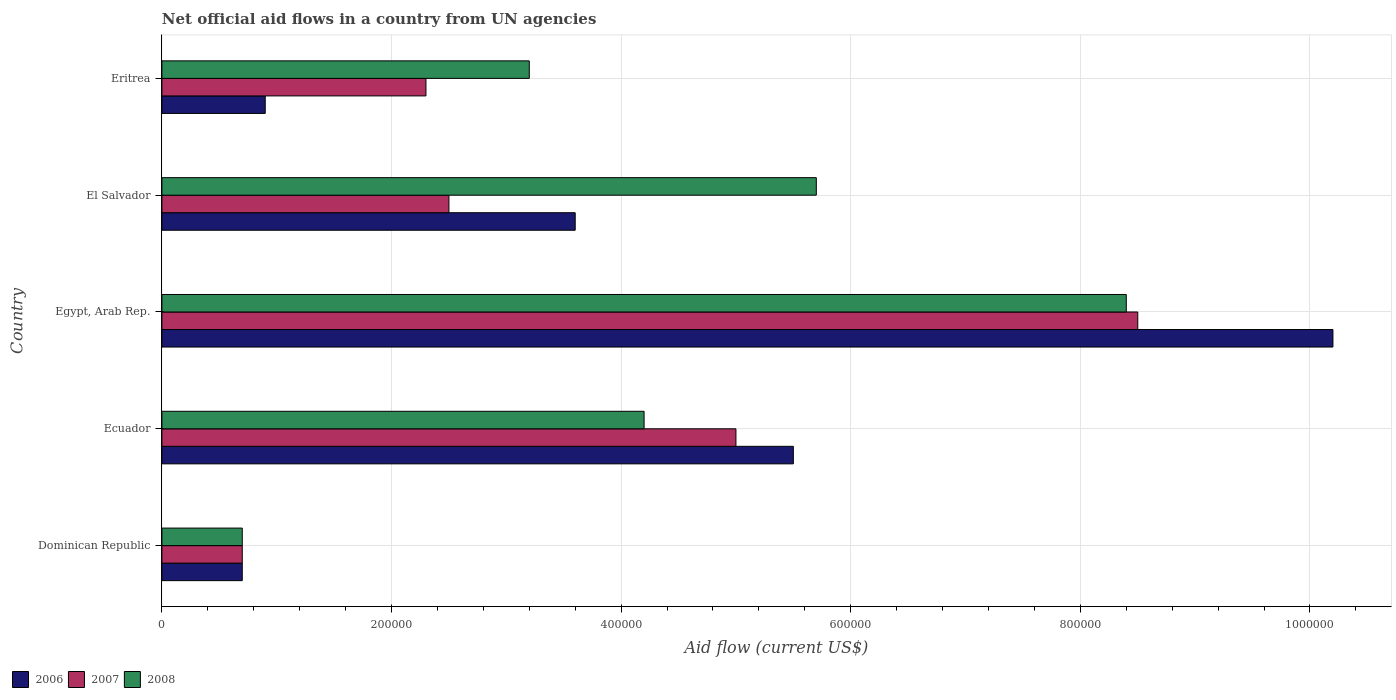How many different coloured bars are there?
Provide a succinct answer. 3. How many groups of bars are there?
Provide a succinct answer. 5. How many bars are there on the 3rd tick from the bottom?
Offer a terse response. 3. What is the label of the 2nd group of bars from the top?
Make the answer very short. El Salvador. Across all countries, what is the maximum net official aid flow in 2008?
Provide a succinct answer. 8.40e+05. Across all countries, what is the minimum net official aid flow in 2007?
Make the answer very short. 7.00e+04. In which country was the net official aid flow in 2008 maximum?
Offer a terse response. Egypt, Arab Rep. In which country was the net official aid flow in 2007 minimum?
Make the answer very short. Dominican Republic. What is the total net official aid flow in 2007 in the graph?
Give a very brief answer. 1.90e+06. What is the difference between the net official aid flow in 2006 in Ecuador and that in Eritrea?
Offer a terse response. 4.60e+05. What is the difference between the net official aid flow in 2006 in El Salvador and the net official aid flow in 2007 in Egypt, Arab Rep.?
Provide a succinct answer. -4.90e+05. What is the average net official aid flow in 2007 per country?
Keep it short and to the point. 3.80e+05. What is the difference between the net official aid flow in 2007 and net official aid flow in 2008 in Egypt, Arab Rep.?
Make the answer very short. 10000. Is the net official aid flow in 2008 in Egypt, Arab Rep. less than that in Eritrea?
Provide a succinct answer. No. Is the difference between the net official aid flow in 2007 in Ecuador and Egypt, Arab Rep. greater than the difference between the net official aid flow in 2008 in Ecuador and Egypt, Arab Rep.?
Your response must be concise. Yes. What is the difference between the highest and the second highest net official aid flow in 2007?
Provide a succinct answer. 3.50e+05. What is the difference between the highest and the lowest net official aid flow in 2007?
Keep it short and to the point. 7.80e+05. Is the sum of the net official aid flow in 2006 in Dominican Republic and Egypt, Arab Rep. greater than the maximum net official aid flow in 2008 across all countries?
Your response must be concise. Yes. What does the 2nd bar from the top in Eritrea represents?
Ensure brevity in your answer.  2007. What does the 3rd bar from the bottom in El Salvador represents?
Your answer should be very brief. 2008. Is it the case that in every country, the sum of the net official aid flow in 2007 and net official aid flow in 2006 is greater than the net official aid flow in 2008?
Ensure brevity in your answer.  No. Are all the bars in the graph horizontal?
Your answer should be very brief. Yes. How many countries are there in the graph?
Your response must be concise. 5. How many legend labels are there?
Make the answer very short. 3. What is the title of the graph?
Keep it short and to the point. Net official aid flows in a country from UN agencies. What is the Aid flow (current US$) in 2006 in Dominican Republic?
Give a very brief answer. 7.00e+04. What is the Aid flow (current US$) in 2008 in Dominican Republic?
Provide a short and direct response. 7.00e+04. What is the Aid flow (current US$) of 2006 in Ecuador?
Offer a very short reply. 5.50e+05. What is the Aid flow (current US$) of 2006 in Egypt, Arab Rep.?
Your response must be concise. 1.02e+06. What is the Aid flow (current US$) of 2007 in Egypt, Arab Rep.?
Make the answer very short. 8.50e+05. What is the Aid flow (current US$) of 2008 in Egypt, Arab Rep.?
Your answer should be compact. 8.40e+05. What is the Aid flow (current US$) in 2007 in El Salvador?
Provide a short and direct response. 2.50e+05. What is the Aid flow (current US$) in 2008 in El Salvador?
Make the answer very short. 5.70e+05. Across all countries, what is the maximum Aid flow (current US$) of 2006?
Offer a very short reply. 1.02e+06. Across all countries, what is the maximum Aid flow (current US$) of 2007?
Offer a very short reply. 8.50e+05. Across all countries, what is the maximum Aid flow (current US$) of 2008?
Provide a short and direct response. 8.40e+05. Across all countries, what is the minimum Aid flow (current US$) of 2007?
Provide a succinct answer. 7.00e+04. Across all countries, what is the minimum Aid flow (current US$) of 2008?
Give a very brief answer. 7.00e+04. What is the total Aid flow (current US$) of 2006 in the graph?
Keep it short and to the point. 2.09e+06. What is the total Aid flow (current US$) in 2007 in the graph?
Your response must be concise. 1.90e+06. What is the total Aid flow (current US$) in 2008 in the graph?
Keep it short and to the point. 2.22e+06. What is the difference between the Aid flow (current US$) in 2006 in Dominican Republic and that in Ecuador?
Your response must be concise. -4.80e+05. What is the difference between the Aid flow (current US$) in 2007 in Dominican Republic and that in Ecuador?
Provide a succinct answer. -4.30e+05. What is the difference between the Aid flow (current US$) of 2008 in Dominican Republic and that in Ecuador?
Provide a succinct answer. -3.50e+05. What is the difference between the Aid flow (current US$) in 2006 in Dominican Republic and that in Egypt, Arab Rep.?
Keep it short and to the point. -9.50e+05. What is the difference between the Aid flow (current US$) of 2007 in Dominican Republic and that in Egypt, Arab Rep.?
Provide a succinct answer. -7.80e+05. What is the difference between the Aid flow (current US$) in 2008 in Dominican Republic and that in Egypt, Arab Rep.?
Offer a terse response. -7.70e+05. What is the difference between the Aid flow (current US$) in 2006 in Dominican Republic and that in El Salvador?
Provide a succinct answer. -2.90e+05. What is the difference between the Aid flow (current US$) in 2007 in Dominican Republic and that in El Salvador?
Keep it short and to the point. -1.80e+05. What is the difference between the Aid flow (current US$) in 2008 in Dominican Republic and that in El Salvador?
Keep it short and to the point. -5.00e+05. What is the difference between the Aid flow (current US$) of 2006 in Dominican Republic and that in Eritrea?
Offer a terse response. -2.00e+04. What is the difference between the Aid flow (current US$) of 2008 in Dominican Republic and that in Eritrea?
Your response must be concise. -2.50e+05. What is the difference between the Aid flow (current US$) of 2006 in Ecuador and that in Egypt, Arab Rep.?
Your answer should be compact. -4.70e+05. What is the difference between the Aid flow (current US$) in 2007 in Ecuador and that in Egypt, Arab Rep.?
Keep it short and to the point. -3.50e+05. What is the difference between the Aid flow (current US$) in 2008 in Ecuador and that in Egypt, Arab Rep.?
Make the answer very short. -4.20e+05. What is the difference between the Aid flow (current US$) of 2007 in Ecuador and that in El Salvador?
Keep it short and to the point. 2.50e+05. What is the difference between the Aid flow (current US$) of 2008 in Ecuador and that in El Salvador?
Ensure brevity in your answer.  -1.50e+05. What is the difference between the Aid flow (current US$) in 2007 in Ecuador and that in Eritrea?
Give a very brief answer. 2.70e+05. What is the difference between the Aid flow (current US$) in 2008 in Egypt, Arab Rep. and that in El Salvador?
Your answer should be very brief. 2.70e+05. What is the difference between the Aid flow (current US$) in 2006 in Egypt, Arab Rep. and that in Eritrea?
Provide a succinct answer. 9.30e+05. What is the difference between the Aid flow (current US$) in 2007 in Egypt, Arab Rep. and that in Eritrea?
Keep it short and to the point. 6.20e+05. What is the difference between the Aid flow (current US$) in 2008 in Egypt, Arab Rep. and that in Eritrea?
Offer a very short reply. 5.20e+05. What is the difference between the Aid flow (current US$) in 2008 in El Salvador and that in Eritrea?
Provide a short and direct response. 2.50e+05. What is the difference between the Aid flow (current US$) of 2006 in Dominican Republic and the Aid flow (current US$) of 2007 in Ecuador?
Provide a succinct answer. -4.30e+05. What is the difference between the Aid flow (current US$) of 2006 in Dominican Republic and the Aid flow (current US$) of 2008 in Ecuador?
Ensure brevity in your answer.  -3.50e+05. What is the difference between the Aid flow (current US$) in 2007 in Dominican Republic and the Aid flow (current US$) in 2008 in Ecuador?
Ensure brevity in your answer.  -3.50e+05. What is the difference between the Aid flow (current US$) in 2006 in Dominican Republic and the Aid flow (current US$) in 2007 in Egypt, Arab Rep.?
Provide a short and direct response. -7.80e+05. What is the difference between the Aid flow (current US$) in 2006 in Dominican Republic and the Aid flow (current US$) in 2008 in Egypt, Arab Rep.?
Keep it short and to the point. -7.70e+05. What is the difference between the Aid flow (current US$) of 2007 in Dominican Republic and the Aid flow (current US$) of 2008 in Egypt, Arab Rep.?
Ensure brevity in your answer.  -7.70e+05. What is the difference between the Aid flow (current US$) of 2006 in Dominican Republic and the Aid flow (current US$) of 2008 in El Salvador?
Give a very brief answer. -5.00e+05. What is the difference between the Aid flow (current US$) of 2007 in Dominican Republic and the Aid flow (current US$) of 2008 in El Salvador?
Ensure brevity in your answer.  -5.00e+05. What is the difference between the Aid flow (current US$) of 2006 in Dominican Republic and the Aid flow (current US$) of 2007 in Eritrea?
Your answer should be very brief. -1.60e+05. What is the difference between the Aid flow (current US$) of 2006 in Ecuador and the Aid flow (current US$) of 2008 in Egypt, Arab Rep.?
Your response must be concise. -2.90e+05. What is the difference between the Aid flow (current US$) in 2007 in Ecuador and the Aid flow (current US$) in 2008 in Egypt, Arab Rep.?
Ensure brevity in your answer.  -3.40e+05. What is the difference between the Aid flow (current US$) in 2006 in Ecuador and the Aid flow (current US$) in 2007 in Eritrea?
Your response must be concise. 3.20e+05. What is the difference between the Aid flow (current US$) of 2006 in Egypt, Arab Rep. and the Aid flow (current US$) of 2007 in El Salvador?
Offer a terse response. 7.70e+05. What is the difference between the Aid flow (current US$) of 2007 in Egypt, Arab Rep. and the Aid flow (current US$) of 2008 in El Salvador?
Ensure brevity in your answer.  2.80e+05. What is the difference between the Aid flow (current US$) in 2006 in Egypt, Arab Rep. and the Aid flow (current US$) in 2007 in Eritrea?
Offer a very short reply. 7.90e+05. What is the difference between the Aid flow (current US$) in 2007 in Egypt, Arab Rep. and the Aid flow (current US$) in 2008 in Eritrea?
Provide a succinct answer. 5.30e+05. What is the difference between the Aid flow (current US$) in 2006 in El Salvador and the Aid flow (current US$) in 2007 in Eritrea?
Your response must be concise. 1.30e+05. What is the difference between the Aid flow (current US$) of 2006 in El Salvador and the Aid flow (current US$) of 2008 in Eritrea?
Provide a short and direct response. 4.00e+04. What is the difference between the Aid flow (current US$) of 2007 in El Salvador and the Aid flow (current US$) of 2008 in Eritrea?
Ensure brevity in your answer.  -7.00e+04. What is the average Aid flow (current US$) of 2006 per country?
Give a very brief answer. 4.18e+05. What is the average Aid flow (current US$) in 2008 per country?
Make the answer very short. 4.44e+05. What is the difference between the Aid flow (current US$) of 2006 and Aid flow (current US$) of 2007 in Dominican Republic?
Make the answer very short. 0. What is the difference between the Aid flow (current US$) of 2006 and Aid flow (current US$) of 2008 in Dominican Republic?
Offer a terse response. 0. What is the difference between the Aid flow (current US$) of 2006 and Aid flow (current US$) of 2008 in Egypt, Arab Rep.?
Provide a succinct answer. 1.80e+05. What is the difference between the Aid flow (current US$) of 2007 and Aid flow (current US$) of 2008 in Egypt, Arab Rep.?
Make the answer very short. 10000. What is the difference between the Aid flow (current US$) of 2006 and Aid flow (current US$) of 2007 in El Salvador?
Make the answer very short. 1.10e+05. What is the difference between the Aid flow (current US$) in 2007 and Aid flow (current US$) in 2008 in El Salvador?
Keep it short and to the point. -3.20e+05. What is the ratio of the Aid flow (current US$) in 2006 in Dominican Republic to that in Ecuador?
Offer a terse response. 0.13. What is the ratio of the Aid flow (current US$) in 2007 in Dominican Republic to that in Ecuador?
Ensure brevity in your answer.  0.14. What is the ratio of the Aid flow (current US$) of 2006 in Dominican Republic to that in Egypt, Arab Rep.?
Make the answer very short. 0.07. What is the ratio of the Aid flow (current US$) in 2007 in Dominican Republic to that in Egypt, Arab Rep.?
Offer a very short reply. 0.08. What is the ratio of the Aid flow (current US$) in 2008 in Dominican Republic to that in Egypt, Arab Rep.?
Your answer should be compact. 0.08. What is the ratio of the Aid flow (current US$) in 2006 in Dominican Republic to that in El Salvador?
Make the answer very short. 0.19. What is the ratio of the Aid flow (current US$) in 2007 in Dominican Republic to that in El Salvador?
Provide a succinct answer. 0.28. What is the ratio of the Aid flow (current US$) in 2008 in Dominican Republic to that in El Salvador?
Offer a very short reply. 0.12. What is the ratio of the Aid flow (current US$) in 2007 in Dominican Republic to that in Eritrea?
Offer a terse response. 0.3. What is the ratio of the Aid flow (current US$) of 2008 in Dominican Republic to that in Eritrea?
Your answer should be very brief. 0.22. What is the ratio of the Aid flow (current US$) in 2006 in Ecuador to that in Egypt, Arab Rep.?
Your answer should be very brief. 0.54. What is the ratio of the Aid flow (current US$) in 2007 in Ecuador to that in Egypt, Arab Rep.?
Provide a succinct answer. 0.59. What is the ratio of the Aid flow (current US$) of 2008 in Ecuador to that in Egypt, Arab Rep.?
Offer a very short reply. 0.5. What is the ratio of the Aid flow (current US$) of 2006 in Ecuador to that in El Salvador?
Ensure brevity in your answer.  1.53. What is the ratio of the Aid flow (current US$) of 2008 in Ecuador to that in El Salvador?
Provide a short and direct response. 0.74. What is the ratio of the Aid flow (current US$) of 2006 in Ecuador to that in Eritrea?
Your answer should be compact. 6.11. What is the ratio of the Aid flow (current US$) in 2007 in Ecuador to that in Eritrea?
Provide a succinct answer. 2.17. What is the ratio of the Aid flow (current US$) in 2008 in Ecuador to that in Eritrea?
Give a very brief answer. 1.31. What is the ratio of the Aid flow (current US$) in 2006 in Egypt, Arab Rep. to that in El Salvador?
Provide a succinct answer. 2.83. What is the ratio of the Aid flow (current US$) of 2008 in Egypt, Arab Rep. to that in El Salvador?
Ensure brevity in your answer.  1.47. What is the ratio of the Aid flow (current US$) in 2006 in Egypt, Arab Rep. to that in Eritrea?
Your response must be concise. 11.33. What is the ratio of the Aid flow (current US$) in 2007 in Egypt, Arab Rep. to that in Eritrea?
Your response must be concise. 3.7. What is the ratio of the Aid flow (current US$) in 2008 in Egypt, Arab Rep. to that in Eritrea?
Offer a terse response. 2.62. What is the ratio of the Aid flow (current US$) of 2007 in El Salvador to that in Eritrea?
Offer a terse response. 1.09. What is the ratio of the Aid flow (current US$) in 2008 in El Salvador to that in Eritrea?
Offer a very short reply. 1.78. What is the difference between the highest and the second highest Aid flow (current US$) of 2006?
Offer a very short reply. 4.70e+05. What is the difference between the highest and the lowest Aid flow (current US$) in 2006?
Your answer should be very brief. 9.50e+05. What is the difference between the highest and the lowest Aid flow (current US$) of 2007?
Give a very brief answer. 7.80e+05. What is the difference between the highest and the lowest Aid flow (current US$) in 2008?
Offer a terse response. 7.70e+05. 